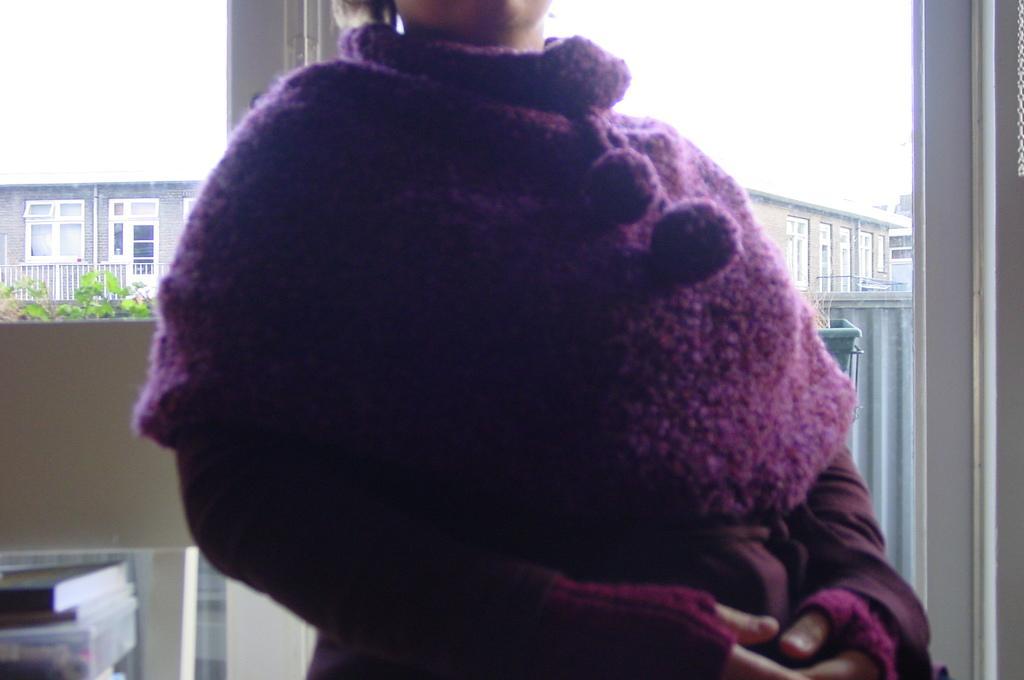Please provide a concise description of this image. In this image we can see there is an inside view of the building and there is a person standing. And at the back there is a book, dustbin, wall, box and a window. Through the window we can see there are buildings, plant and the sky. 